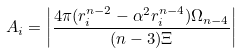<formula> <loc_0><loc_0><loc_500><loc_500>A _ { i } = \left | \frac { 4 \pi ( r ^ { n - 2 } _ { i } - \alpha ^ { 2 } r ^ { n - 4 } _ { i } ) \Omega _ { n - 4 } } { ( n - 3 ) \Xi } \right |</formula> 